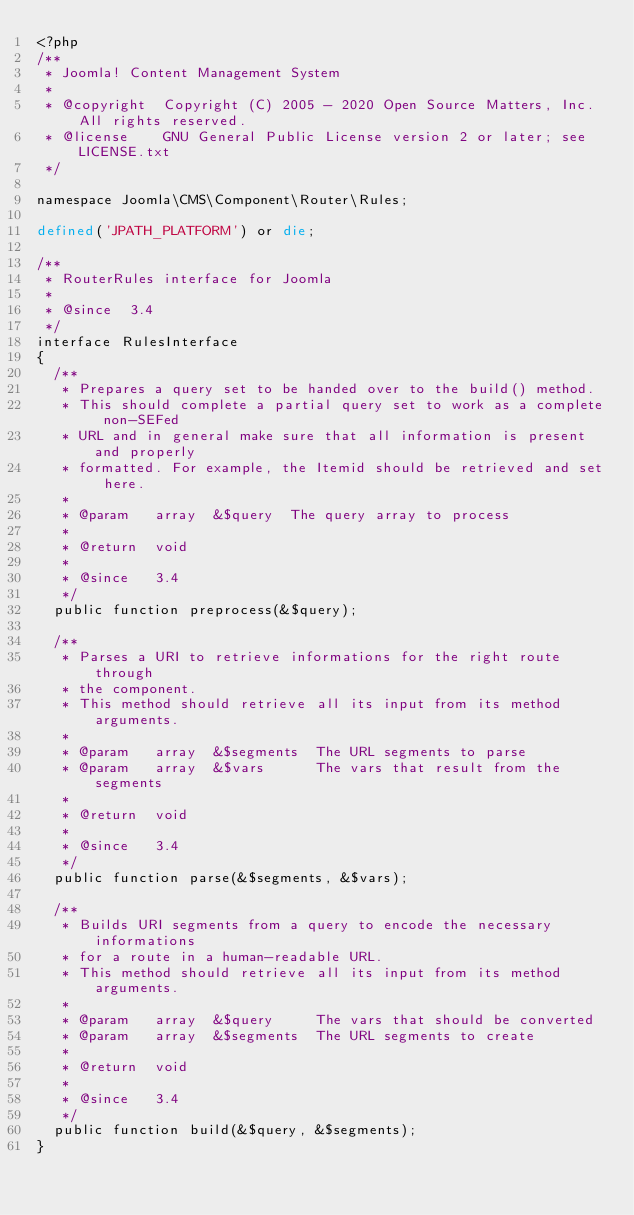Convert code to text. <code><loc_0><loc_0><loc_500><loc_500><_PHP_><?php
/**
 * Joomla! Content Management System
 *
 * @copyright  Copyright (C) 2005 - 2020 Open Source Matters, Inc. All rights reserved.
 * @license    GNU General Public License version 2 or later; see LICENSE.txt
 */

namespace Joomla\CMS\Component\Router\Rules;

defined('JPATH_PLATFORM') or die;

/**
 * RouterRules interface for Joomla
 *
 * @since  3.4
 */
interface RulesInterface
{
	/**
	 * Prepares a query set to be handed over to the build() method.
	 * This should complete a partial query set to work as a complete non-SEFed
	 * URL and in general make sure that all information is present and properly
	 * formatted. For example, the Itemid should be retrieved and set here.
	 *
	 * @param   array  &$query  The query array to process
	 *
	 * @return  void
	 *
	 * @since   3.4
	 */
	public function preprocess(&$query);

	/**
	 * Parses a URI to retrieve informations for the right route through
	 * the component.
	 * This method should retrieve all its input from its method arguments.
	 *
	 * @param   array  &$segments  The URL segments to parse
	 * @param   array  &$vars      The vars that result from the segments
	 *
	 * @return  void
	 *
	 * @since   3.4
	 */
	public function parse(&$segments, &$vars);

	/**
	 * Builds URI segments from a query to encode the necessary informations
	 * for a route in a human-readable URL.
	 * This method should retrieve all its input from its method arguments.
	 *
	 * @param   array  &$query     The vars that should be converted
	 * @param   array  &$segments  The URL segments to create
	 *
	 * @return  void
	 *
	 * @since   3.4
	 */
	public function build(&$query, &$segments);
}
</code> 